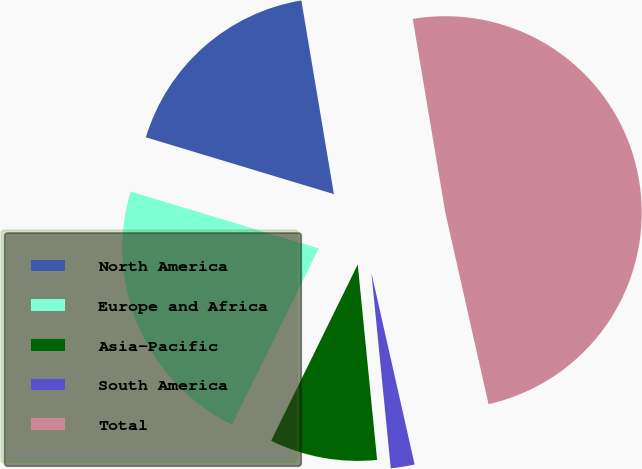Convert chart. <chart><loc_0><loc_0><loc_500><loc_500><pie_chart><fcel>North America<fcel>Europe and Africa<fcel>Asia-Pacific<fcel>South America<fcel>Total<nl><fcel>17.68%<fcel>22.4%<fcel>8.84%<fcel>1.96%<fcel>49.12%<nl></chart> 